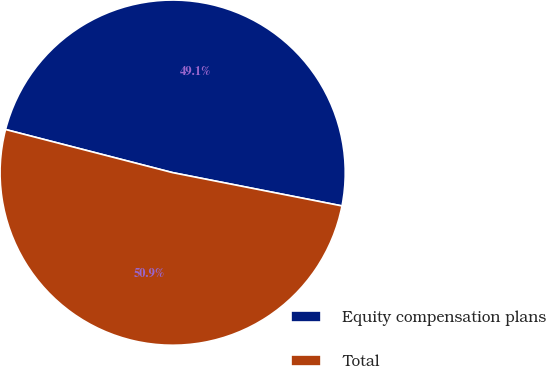<chart> <loc_0><loc_0><loc_500><loc_500><pie_chart><fcel>Equity compensation plans<fcel>Total<nl><fcel>49.07%<fcel>50.93%<nl></chart> 